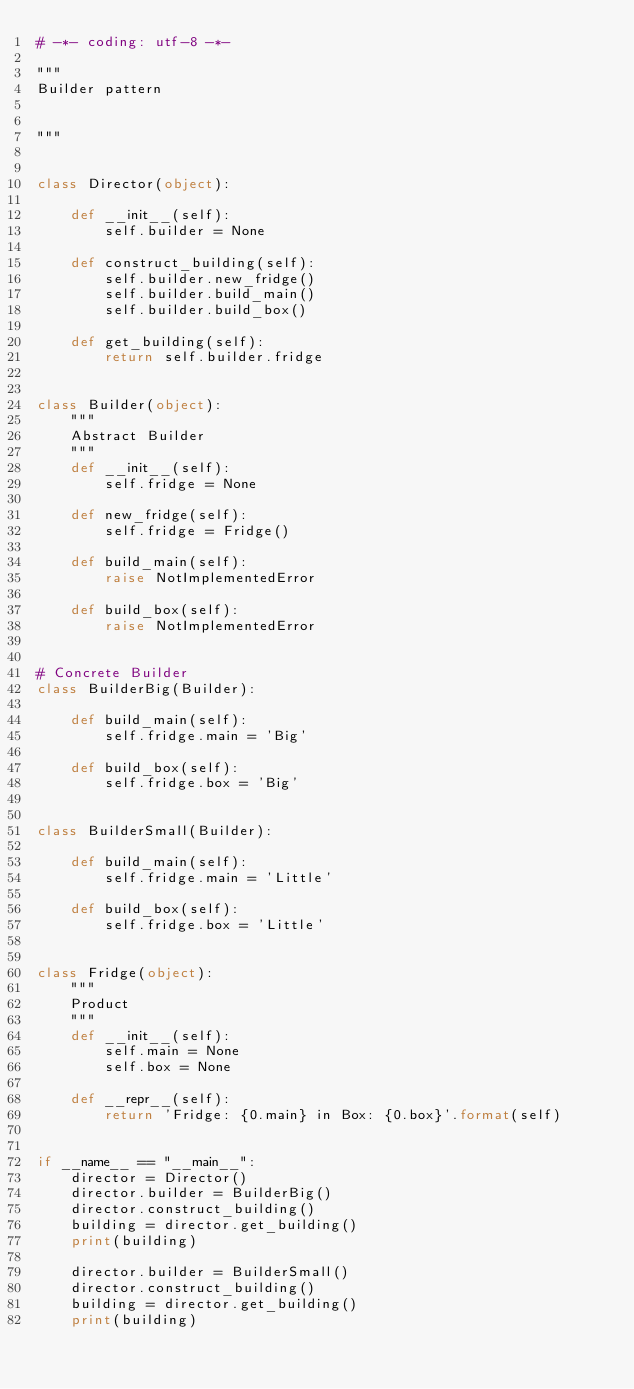Convert code to text. <code><loc_0><loc_0><loc_500><loc_500><_Python_># -*- coding: utf-8 -*-

"""
Builder pattern


"""


class Director(object):

    def __init__(self):
        self.builder = None

    def construct_building(self):
        self.builder.new_fridge()
        self.builder.build_main()
        self.builder.build_box()

    def get_building(self):
        return self.builder.fridge


class Builder(object):
    """
    Abstract Builder
    """
    def __init__(self):
        self.fridge = None

    def new_fridge(self):
        self.fridge = Fridge()

    def build_main(self):
        raise NotImplementedError

    def build_box(self):
        raise NotImplementedError


# Concrete Builder
class BuilderBig(Builder):

    def build_main(self):
        self.fridge.main = 'Big'

    def build_box(self):
        self.fridge.box = 'Big'


class BuilderSmall(Builder):

    def build_main(self):
        self.fridge.main = 'Little'

    def build_box(self):
        self.fridge.box = 'Little'


class Fridge(object):
    """
    Product
    """
    def __init__(self):
        self.main = None
        self.box = None

    def __repr__(self):
        return 'Fridge: {0.main} in Box: {0.box}'.format(self)


if __name__ == "__main__":
    director = Director()
    director.builder = BuilderBig()
    director.construct_building()
    building = director.get_building()
    print(building)

    director.builder = BuilderSmall()
    director.construct_building()
    building = director.get_building()
    print(building)




</code> 